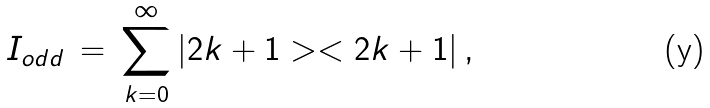Convert formula to latex. <formula><loc_0><loc_0><loc_500><loc_500>I _ { o d d } \, = \, \sum _ { k = 0 } ^ { \infty } | 2 k + 1 > < 2 k + 1 | \, ,</formula> 